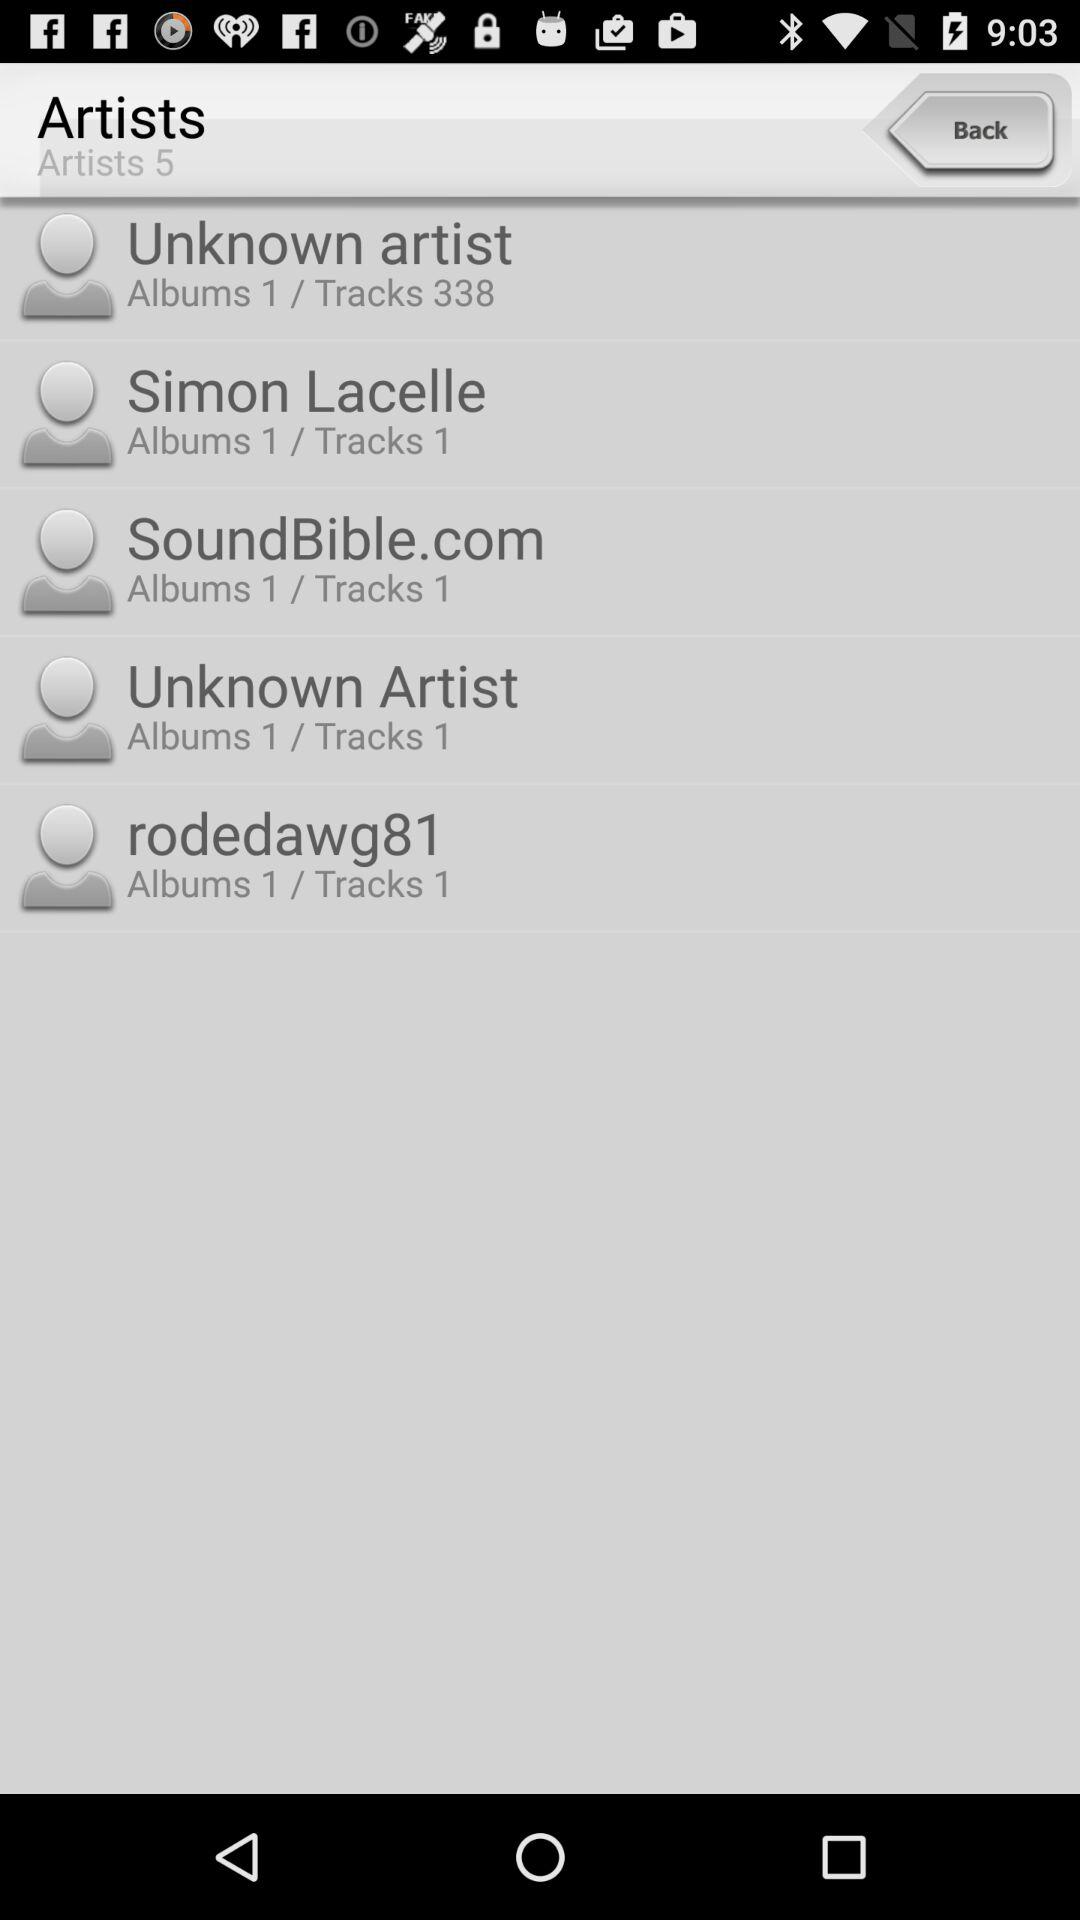How many albums does "rodedawg81" contain? "rodedawg81" contains 1 album. 